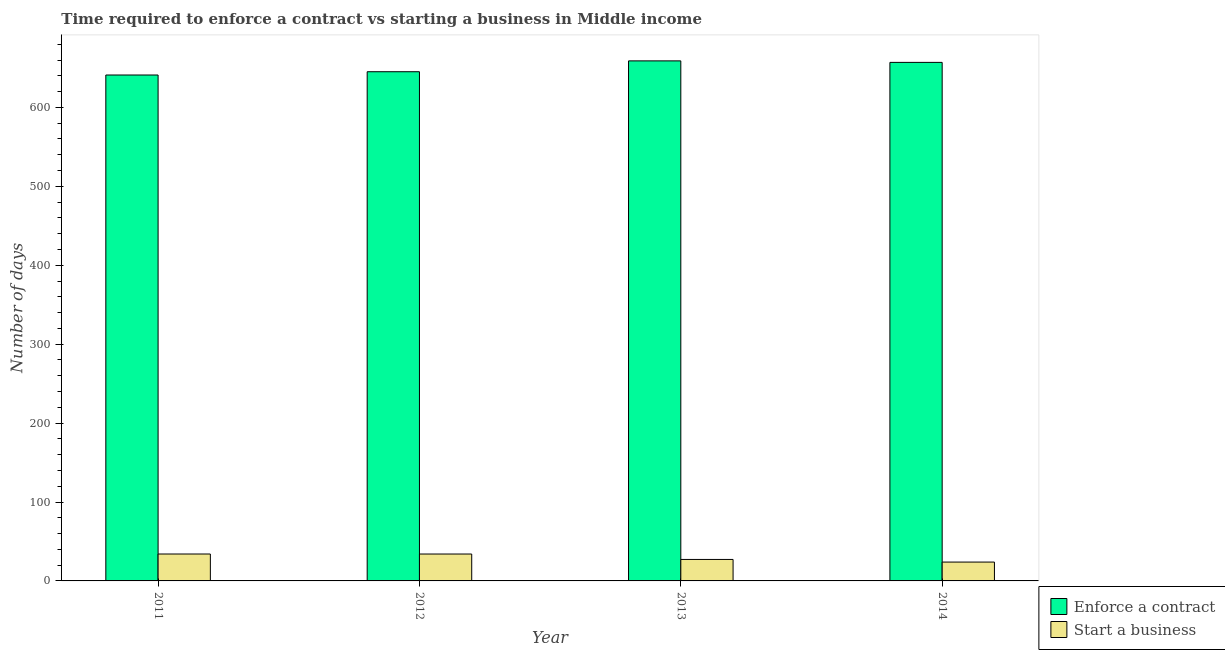How many different coloured bars are there?
Keep it short and to the point. 2. Are the number of bars on each tick of the X-axis equal?
Offer a very short reply. Yes. How many bars are there on the 4th tick from the right?
Keep it short and to the point. 2. What is the label of the 3rd group of bars from the left?
Ensure brevity in your answer.  2013. In how many cases, is the number of bars for a given year not equal to the number of legend labels?
Keep it short and to the point. 0. What is the number of days to enforece a contract in 2011?
Keep it short and to the point. 641.06. Across all years, what is the maximum number of days to start a business?
Your answer should be compact. 34.1. Across all years, what is the minimum number of days to start a business?
Ensure brevity in your answer.  23.9. In which year was the number of days to enforece a contract maximum?
Provide a short and direct response. 2013. In which year was the number of days to start a business minimum?
Provide a short and direct response. 2014. What is the total number of days to start a business in the graph?
Give a very brief answer. 119.28. What is the difference between the number of days to start a business in 2013 and that in 2014?
Offer a very short reply. 3.31. What is the difference between the number of days to start a business in 2014 and the number of days to enforece a contract in 2013?
Your answer should be very brief. -3.31. What is the average number of days to start a business per year?
Ensure brevity in your answer.  29.82. What is the ratio of the number of days to start a business in 2012 to that in 2013?
Offer a very short reply. 1.25. What is the difference between the highest and the second highest number of days to enforece a contract?
Your answer should be compact. 1.9. What is the difference between the highest and the lowest number of days to start a business?
Offer a terse response. 10.2. In how many years, is the number of days to enforece a contract greater than the average number of days to enforece a contract taken over all years?
Make the answer very short. 2. Is the sum of the number of days to enforece a contract in 2011 and 2014 greater than the maximum number of days to start a business across all years?
Your answer should be very brief. Yes. What does the 2nd bar from the left in 2013 represents?
Offer a terse response. Start a business. What does the 2nd bar from the right in 2013 represents?
Your response must be concise. Enforce a contract. How many bars are there?
Provide a short and direct response. 8. What is the difference between two consecutive major ticks on the Y-axis?
Your answer should be very brief. 100. Does the graph contain grids?
Provide a short and direct response. No. How many legend labels are there?
Ensure brevity in your answer.  2. How are the legend labels stacked?
Your answer should be compact. Vertical. What is the title of the graph?
Provide a succinct answer. Time required to enforce a contract vs starting a business in Middle income. Does "Commercial bank branches" appear as one of the legend labels in the graph?
Your answer should be very brief. No. What is the label or title of the Y-axis?
Your response must be concise. Number of days. What is the Number of days of Enforce a contract in 2011?
Give a very brief answer. 641.06. What is the Number of days of Start a business in 2011?
Your response must be concise. 34.1. What is the Number of days of Enforce a contract in 2012?
Your answer should be compact. 645.22. What is the Number of days in Start a business in 2012?
Ensure brevity in your answer.  34.08. What is the Number of days of Enforce a contract in 2013?
Your response must be concise. 658.96. What is the Number of days of Start a business in 2013?
Ensure brevity in your answer.  27.21. What is the Number of days in Enforce a contract in 2014?
Your answer should be very brief. 657.06. What is the Number of days of Start a business in 2014?
Your response must be concise. 23.9. Across all years, what is the maximum Number of days in Enforce a contract?
Your answer should be very brief. 658.96. Across all years, what is the maximum Number of days in Start a business?
Provide a short and direct response. 34.1. Across all years, what is the minimum Number of days of Enforce a contract?
Provide a short and direct response. 641.06. Across all years, what is the minimum Number of days of Start a business?
Your response must be concise. 23.9. What is the total Number of days of Enforce a contract in the graph?
Offer a terse response. 2602.29. What is the total Number of days in Start a business in the graph?
Offer a very short reply. 119.28. What is the difference between the Number of days of Enforce a contract in 2011 and that in 2012?
Offer a very short reply. -4.16. What is the difference between the Number of days of Start a business in 2011 and that in 2012?
Offer a very short reply. 0.02. What is the difference between the Number of days of Enforce a contract in 2011 and that in 2013?
Provide a short and direct response. -17.9. What is the difference between the Number of days in Start a business in 2011 and that in 2013?
Offer a very short reply. 6.89. What is the difference between the Number of days in Enforce a contract in 2011 and that in 2014?
Make the answer very short. -16. What is the difference between the Number of days in Start a business in 2011 and that in 2014?
Offer a very short reply. 10.2. What is the difference between the Number of days of Enforce a contract in 2012 and that in 2013?
Offer a very short reply. -13.74. What is the difference between the Number of days in Start a business in 2012 and that in 2013?
Ensure brevity in your answer.  6.88. What is the difference between the Number of days of Enforce a contract in 2012 and that in 2014?
Offer a very short reply. -11.84. What is the difference between the Number of days in Start a business in 2012 and that in 2014?
Your answer should be compact. 10.19. What is the difference between the Number of days in Start a business in 2013 and that in 2014?
Provide a succinct answer. 3.31. What is the difference between the Number of days of Enforce a contract in 2011 and the Number of days of Start a business in 2012?
Ensure brevity in your answer.  606.97. What is the difference between the Number of days in Enforce a contract in 2011 and the Number of days in Start a business in 2013?
Your answer should be very brief. 613.85. What is the difference between the Number of days of Enforce a contract in 2011 and the Number of days of Start a business in 2014?
Your answer should be compact. 617.16. What is the difference between the Number of days in Enforce a contract in 2012 and the Number of days in Start a business in 2013?
Give a very brief answer. 618.01. What is the difference between the Number of days in Enforce a contract in 2012 and the Number of days in Start a business in 2014?
Give a very brief answer. 621.32. What is the difference between the Number of days in Enforce a contract in 2013 and the Number of days in Start a business in 2014?
Your response must be concise. 635.06. What is the average Number of days in Enforce a contract per year?
Your answer should be very brief. 650.57. What is the average Number of days in Start a business per year?
Your answer should be compact. 29.82. In the year 2011, what is the difference between the Number of days of Enforce a contract and Number of days of Start a business?
Give a very brief answer. 606.96. In the year 2012, what is the difference between the Number of days in Enforce a contract and Number of days in Start a business?
Keep it short and to the point. 611.14. In the year 2013, what is the difference between the Number of days in Enforce a contract and Number of days in Start a business?
Ensure brevity in your answer.  631.75. In the year 2014, what is the difference between the Number of days of Enforce a contract and Number of days of Start a business?
Give a very brief answer. 633.16. What is the ratio of the Number of days of Enforce a contract in 2011 to that in 2012?
Your answer should be very brief. 0.99. What is the ratio of the Number of days of Start a business in 2011 to that in 2012?
Offer a terse response. 1. What is the ratio of the Number of days in Enforce a contract in 2011 to that in 2013?
Ensure brevity in your answer.  0.97. What is the ratio of the Number of days of Start a business in 2011 to that in 2013?
Keep it short and to the point. 1.25. What is the ratio of the Number of days in Enforce a contract in 2011 to that in 2014?
Give a very brief answer. 0.98. What is the ratio of the Number of days of Start a business in 2011 to that in 2014?
Your answer should be compact. 1.43. What is the ratio of the Number of days of Enforce a contract in 2012 to that in 2013?
Offer a terse response. 0.98. What is the ratio of the Number of days of Start a business in 2012 to that in 2013?
Provide a succinct answer. 1.25. What is the ratio of the Number of days in Enforce a contract in 2012 to that in 2014?
Ensure brevity in your answer.  0.98. What is the ratio of the Number of days of Start a business in 2012 to that in 2014?
Give a very brief answer. 1.43. What is the ratio of the Number of days in Enforce a contract in 2013 to that in 2014?
Keep it short and to the point. 1. What is the ratio of the Number of days of Start a business in 2013 to that in 2014?
Offer a very short reply. 1.14. What is the difference between the highest and the second highest Number of days of Enforce a contract?
Offer a very short reply. 1.9. What is the difference between the highest and the second highest Number of days in Start a business?
Ensure brevity in your answer.  0.02. What is the difference between the highest and the lowest Number of days of Enforce a contract?
Your answer should be compact. 17.9. What is the difference between the highest and the lowest Number of days in Start a business?
Make the answer very short. 10.2. 